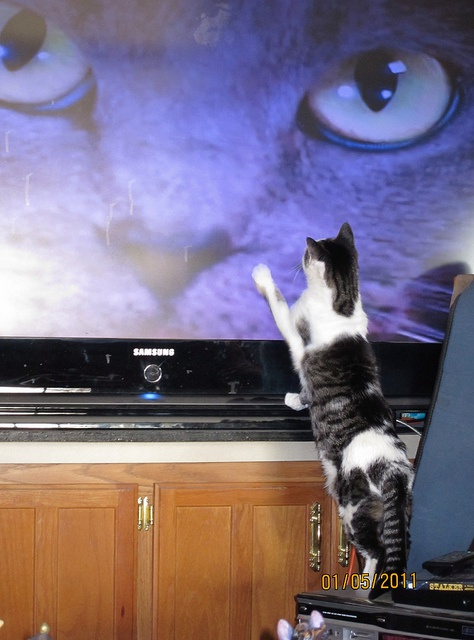Describe the objects in this image and their specific colors. I can see tv in gray, violet, blue, black, and lavender tones, cat in gray, black, lightgray, and darkgray tones, and remote in gray and black tones in this image. 